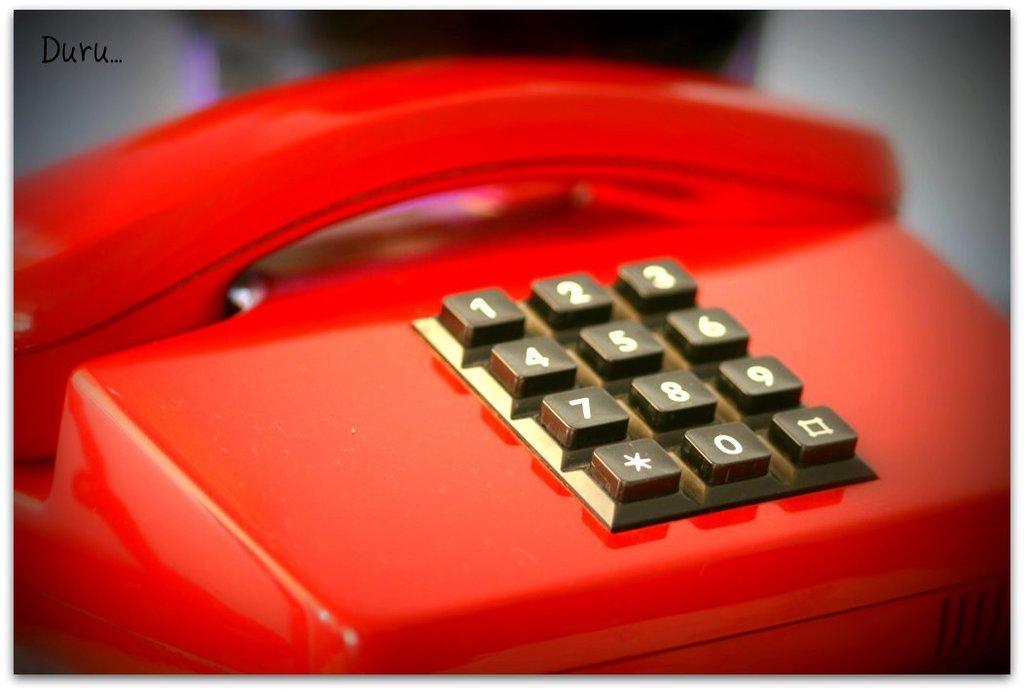Can you describe this image briefly? In this picture we can see a red telephone with numbers on it and in the background it is blurry. 